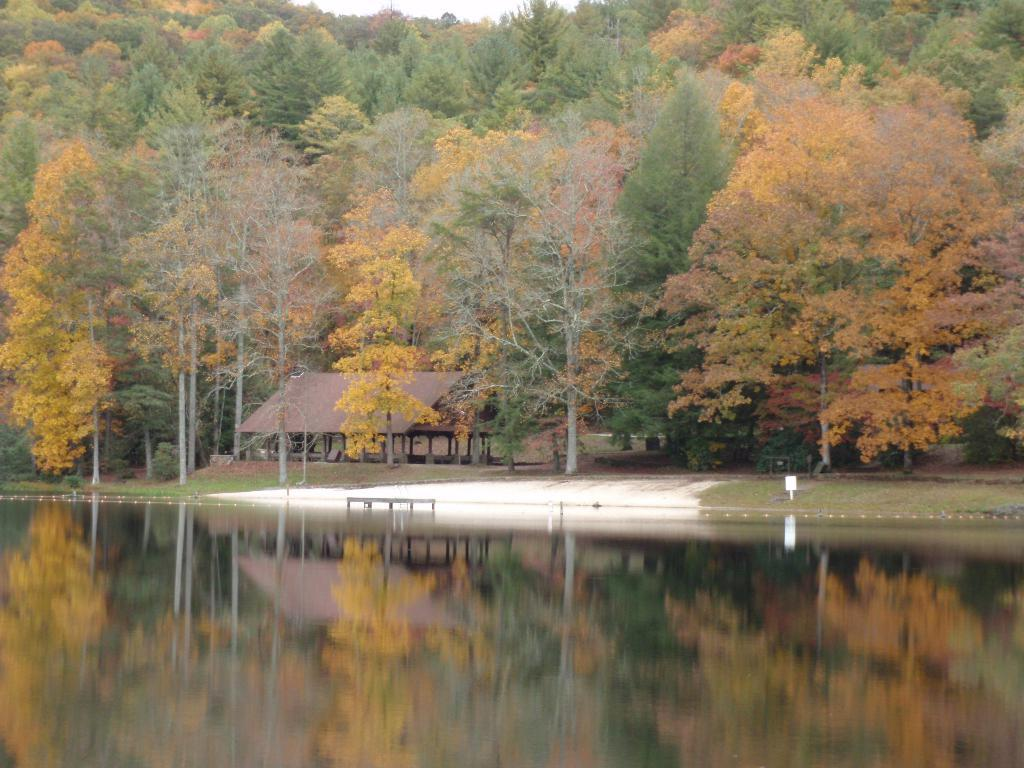What type of vegetation is visible in the image? There are trees in the image. What natural element can be seen in the image besides trees? There is water visible in the image. What structure is located in the middle of the image? There is a shelter in the middle of the image. Can you see any partner dancing near the shelter in the image? There is no partner dancing near the shelter in the image. Are there any icicles hanging from the trees in the image? There are no icicles present in the image. Is there a police officer patrolling near the water in the image? There is no police officer present in the image. 